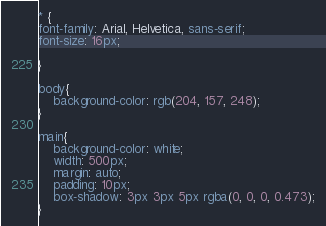<code> <loc_0><loc_0><loc_500><loc_500><_CSS_>* {
font-family: Arial, Helvetica, sans-serif;
font-size: 16px;

}

body{
    background-color: rgb(204, 157, 248);
}

main{
    background-color: white;
    width: 500px;
    margin: auto;
    padding: 10px;
    box-shadow: 3px 3px 5px rgba(0, 0, 0, 0.473);
}</code> 